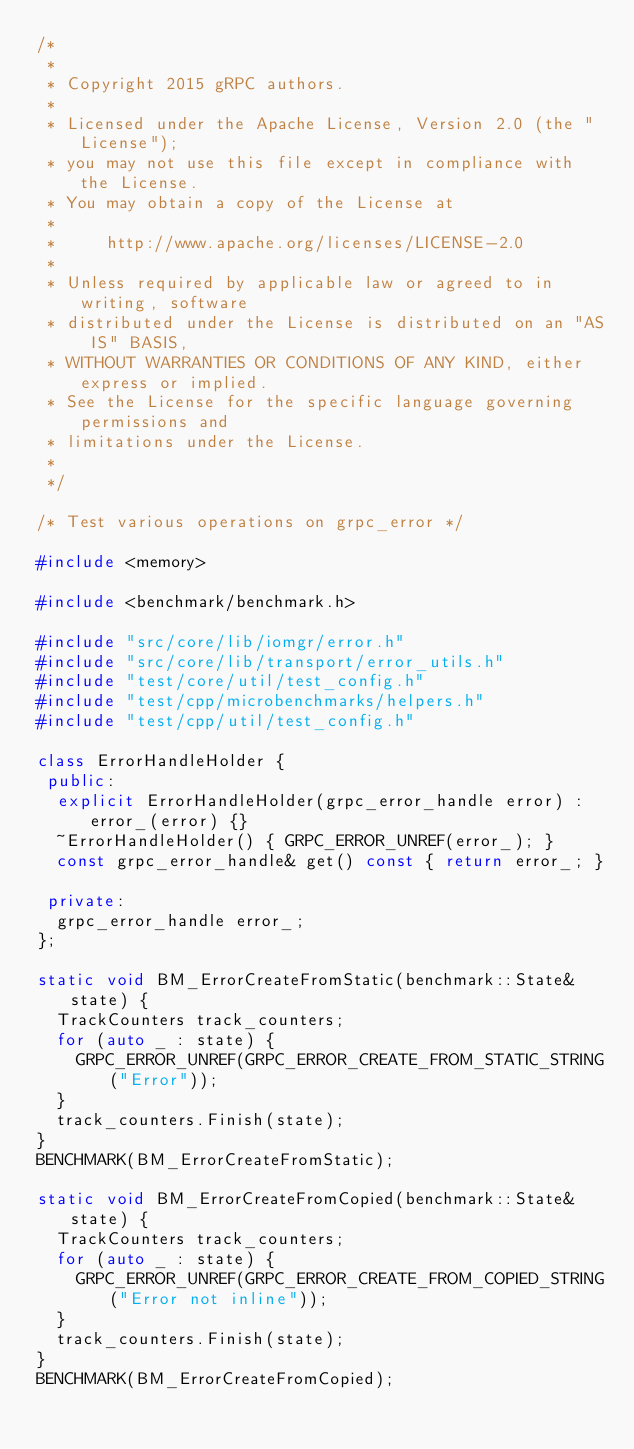Convert code to text. <code><loc_0><loc_0><loc_500><loc_500><_C++_>/*
 *
 * Copyright 2015 gRPC authors.
 *
 * Licensed under the Apache License, Version 2.0 (the "License");
 * you may not use this file except in compliance with the License.
 * You may obtain a copy of the License at
 *
 *     http://www.apache.org/licenses/LICENSE-2.0
 *
 * Unless required by applicable law or agreed to in writing, software
 * distributed under the License is distributed on an "AS IS" BASIS,
 * WITHOUT WARRANTIES OR CONDITIONS OF ANY KIND, either express or implied.
 * See the License for the specific language governing permissions and
 * limitations under the License.
 *
 */

/* Test various operations on grpc_error */

#include <memory>

#include <benchmark/benchmark.h>

#include "src/core/lib/iomgr/error.h"
#include "src/core/lib/transport/error_utils.h"
#include "test/core/util/test_config.h"
#include "test/cpp/microbenchmarks/helpers.h"
#include "test/cpp/util/test_config.h"

class ErrorHandleHolder {
 public:
  explicit ErrorHandleHolder(grpc_error_handle error) : error_(error) {}
  ~ErrorHandleHolder() { GRPC_ERROR_UNREF(error_); }
  const grpc_error_handle& get() const { return error_; }

 private:
  grpc_error_handle error_;
};

static void BM_ErrorCreateFromStatic(benchmark::State& state) {
  TrackCounters track_counters;
  for (auto _ : state) {
    GRPC_ERROR_UNREF(GRPC_ERROR_CREATE_FROM_STATIC_STRING("Error"));
  }
  track_counters.Finish(state);
}
BENCHMARK(BM_ErrorCreateFromStatic);

static void BM_ErrorCreateFromCopied(benchmark::State& state) {
  TrackCounters track_counters;
  for (auto _ : state) {
    GRPC_ERROR_UNREF(GRPC_ERROR_CREATE_FROM_COPIED_STRING("Error not inline"));
  }
  track_counters.Finish(state);
}
BENCHMARK(BM_ErrorCreateFromCopied);
</code> 